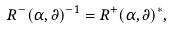Convert formula to latex. <formula><loc_0><loc_0><loc_500><loc_500>R ^ { - } ( \alpha , \partial ) ^ { - 1 } = R ^ { + } ( \alpha , \partial ) ^ { * } ,</formula> 